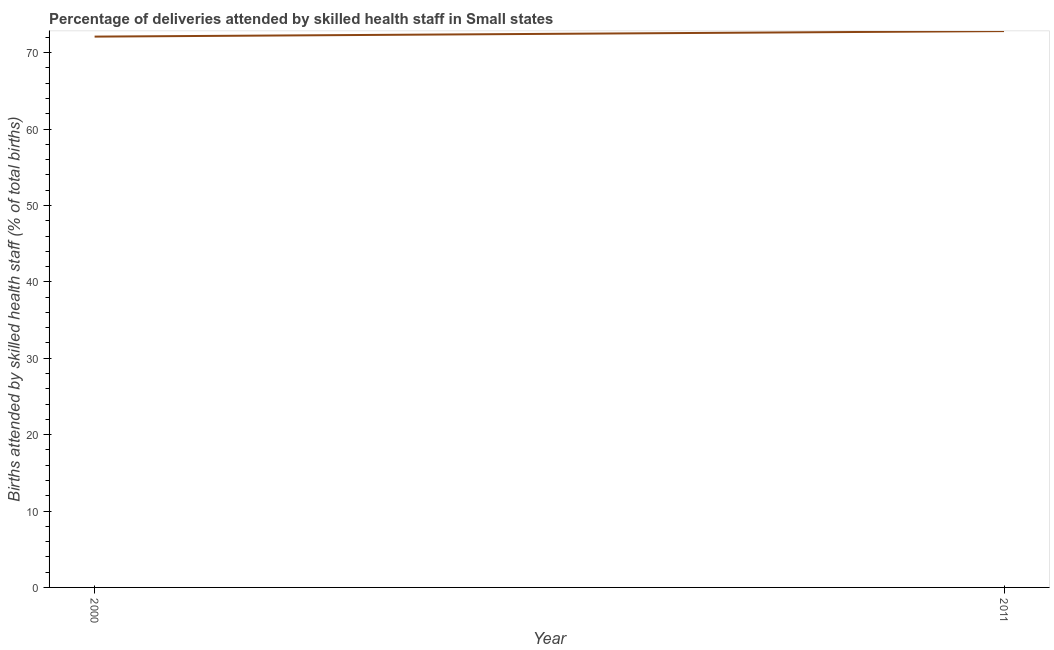What is the number of births attended by skilled health staff in 2011?
Your response must be concise. 72.83. Across all years, what is the maximum number of births attended by skilled health staff?
Ensure brevity in your answer.  72.83. Across all years, what is the minimum number of births attended by skilled health staff?
Offer a terse response. 72.11. In which year was the number of births attended by skilled health staff minimum?
Keep it short and to the point. 2000. What is the sum of the number of births attended by skilled health staff?
Provide a succinct answer. 144.93. What is the difference between the number of births attended by skilled health staff in 2000 and 2011?
Make the answer very short. -0.72. What is the average number of births attended by skilled health staff per year?
Your response must be concise. 72.47. What is the median number of births attended by skilled health staff?
Give a very brief answer. 72.47. In how many years, is the number of births attended by skilled health staff greater than 70 %?
Offer a terse response. 2. Do a majority of the years between 2011 and 2000 (inclusive) have number of births attended by skilled health staff greater than 6 %?
Provide a succinct answer. No. What is the ratio of the number of births attended by skilled health staff in 2000 to that in 2011?
Your answer should be very brief. 0.99. Is the number of births attended by skilled health staff in 2000 less than that in 2011?
Keep it short and to the point. Yes. In how many years, is the number of births attended by skilled health staff greater than the average number of births attended by skilled health staff taken over all years?
Your answer should be very brief. 1. How many years are there in the graph?
Your answer should be very brief. 2. What is the difference between two consecutive major ticks on the Y-axis?
Make the answer very short. 10. Are the values on the major ticks of Y-axis written in scientific E-notation?
Ensure brevity in your answer.  No. Does the graph contain grids?
Keep it short and to the point. No. What is the title of the graph?
Provide a short and direct response. Percentage of deliveries attended by skilled health staff in Small states. What is the label or title of the Y-axis?
Keep it short and to the point. Births attended by skilled health staff (% of total births). What is the Births attended by skilled health staff (% of total births) in 2000?
Provide a short and direct response. 72.11. What is the Births attended by skilled health staff (% of total births) in 2011?
Offer a very short reply. 72.83. What is the difference between the Births attended by skilled health staff (% of total births) in 2000 and 2011?
Make the answer very short. -0.72. What is the ratio of the Births attended by skilled health staff (% of total births) in 2000 to that in 2011?
Ensure brevity in your answer.  0.99. 